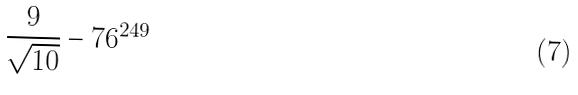<formula> <loc_0><loc_0><loc_500><loc_500>\frac { 9 } { \sqrt { 1 0 } } - 7 6 ^ { 2 4 9 }</formula> 